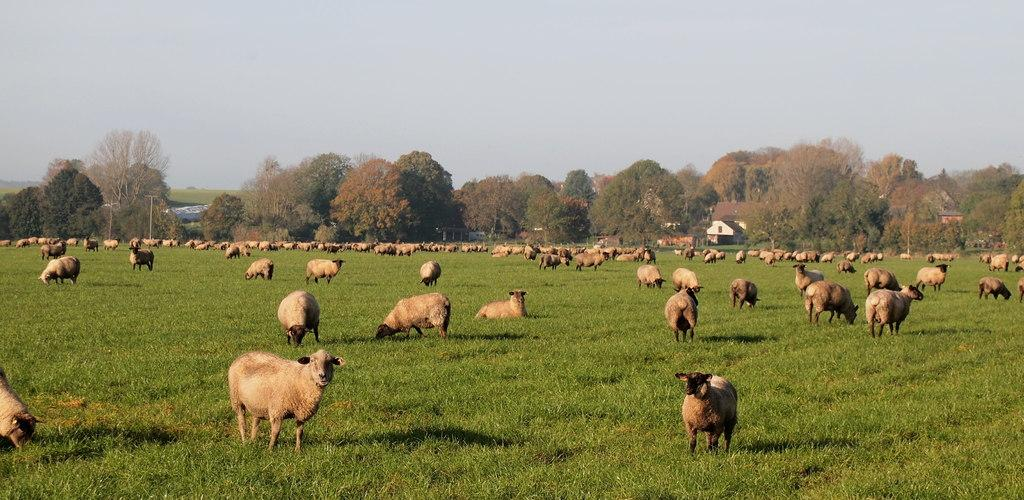What types of living organisms can be seen in the image? There are animals in the image. What is the terrain like in the image? The ground with grass is visible in the image. What type of vegetation is present in the image? There are trees in the image. What type of structures can be seen in the image? There are houses in the image. What is visible in the background of the image? The sky is visible in the image. What is the value of the wax in the image? There is no wax present in the image, so it is not possible to determine its value. 